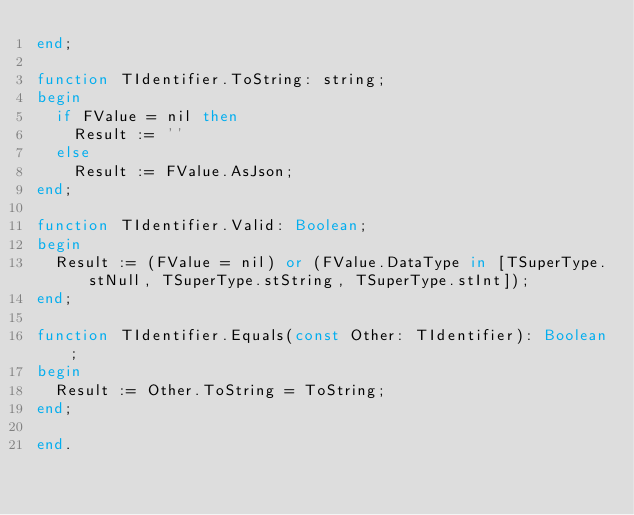<code> <loc_0><loc_0><loc_500><loc_500><_Pascal_>end;

function TIdentifier.ToString: string;
begin
  if FValue = nil then
    Result := ''
  else
    Result := FValue.AsJson;
end;

function TIdentifier.Valid: Boolean;
begin
  Result := (FValue = nil) or (FValue.DataType in [TSuperType.stNull, TSuperType.stString, TSuperType.stInt]);
end;

function TIdentifier.Equals(const Other: TIdentifier): Boolean;
begin
  Result := Other.ToString = ToString;
end;

end.
</code> 